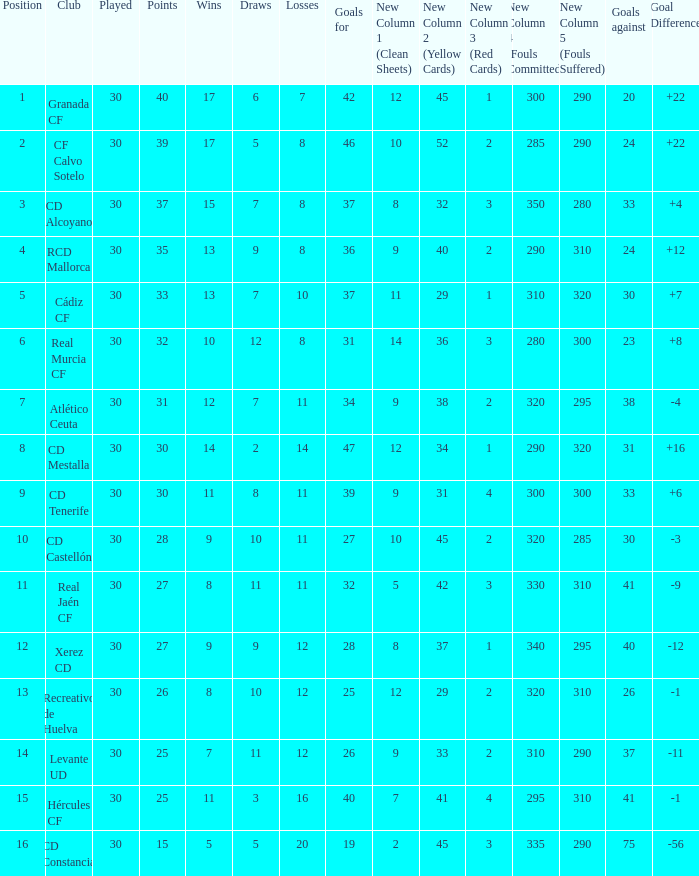How many Wins have Goals against smaller than 30, and Goals for larger than 25, and Draws larger than 5? 3.0. 